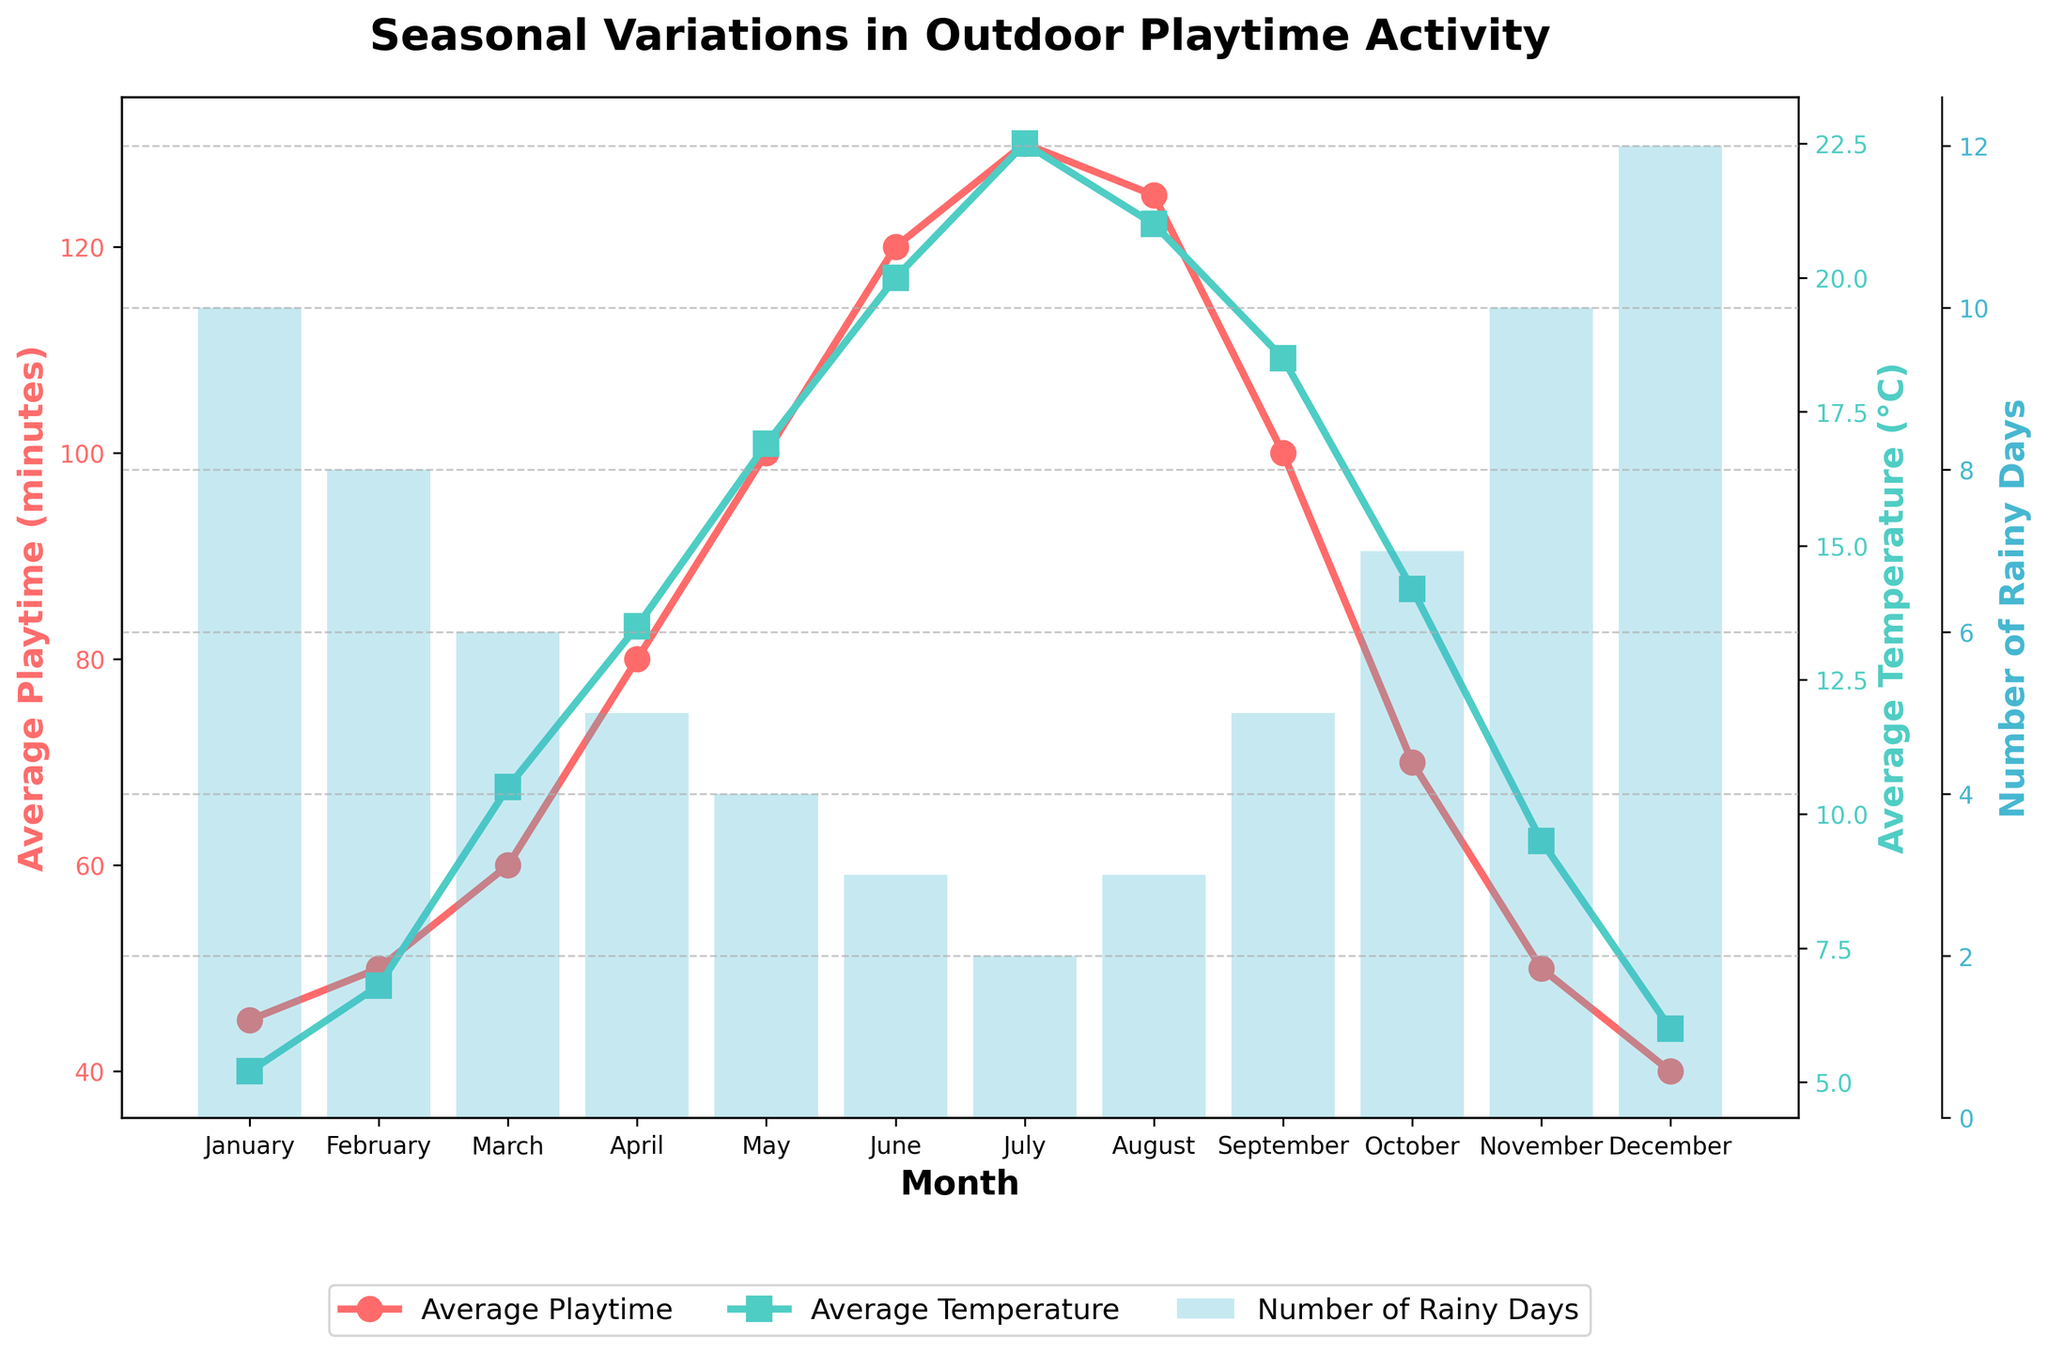What is the title of the figure? The title is always displayed at the top of the figure, making it easy to identify.
Answer: Seasonal Variations in Outdoor Playtime Activity Which month has the highest average playtime? Look at the line labeled 'Average Playtime' and find the month where the line peaks.
Answer: July How many months have more than 100 minutes of average playtime? Identify the segments of the 'Average Playtime' line that are above 100 minutes and count the months.
Answer: 4 Which month has the highest number of rainy days? Locate the bar chart indicating 'Number of Rainy Days' and find the tallest bar.
Answer: December What is the temperature range throughout the year according to the plot? Find the minimum and maximum points on the 'Average Temperature' line and calculate the difference.
Answer: 5.2°C to 22.5°C, so the range is 17.3°C Compare the average playtime in June and November. Which month has more playtime? Locate the points for June and November on the 'Average Playtime' line and compare their values.
Answer: June In which month do you observe the most significant increase in average playtime from the previous month? Observe the consecutive points on the 'Average Playtime' line and identify the steepest upward slope.
Answer: April to May Does higher average temperature generally correspond to higher average playtime? Compare the trends of the 'Average Temperature' and 'Average Playtime' lines to see if they move in the same direction.
Answer: Yes Between which two consecutive months is the decrease in the number of rainy days the greatest? Observe the bar chart and identify the largest drop when moving from one month to the next.
Answer: December to January Which season has the lowest average temperature and average playtime? Group the months into seasons (Winter: Dec-Feb, Spring: Mar-May, Summer: Jun-Aug, Fall: Sep-Nov) and compare their average temperatures and playtimes.
Answer: Winter 